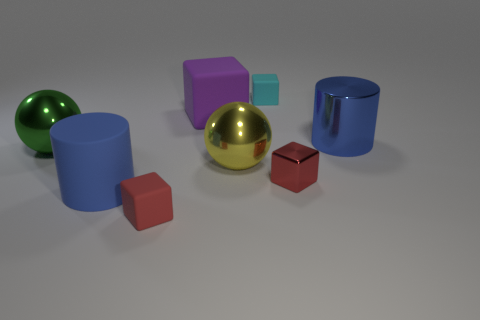There is a shiny cylinder that is the same size as the green object; what color is it?
Your answer should be very brief. Blue. How many cubes are either small red rubber things or big rubber objects?
Offer a very short reply. 2. How many large yellow shiny balls are there?
Ensure brevity in your answer.  1. There is a big green metallic object; does it have the same shape as the big metal thing in front of the big green metal thing?
Provide a short and direct response. Yes. There is a thing that is the same color as the rubber cylinder; what size is it?
Keep it short and to the point. Large. What number of objects are yellow cubes or green things?
Keep it short and to the point. 1. There is a small cyan rubber thing behind the cylinder that is left of the small cyan thing; what shape is it?
Your response must be concise. Cube. Is the shape of the tiny red thing that is to the right of the tiny cyan matte thing the same as  the big purple rubber thing?
Ensure brevity in your answer.  Yes. What size is the purple object that is the same material as the cyan block?
Your response must be concise. Large. How many things are large blue cylinders in front of the large green ball or metallic things that are to the right of the small cyan rubber object?
Offer a very short reply. 3. 